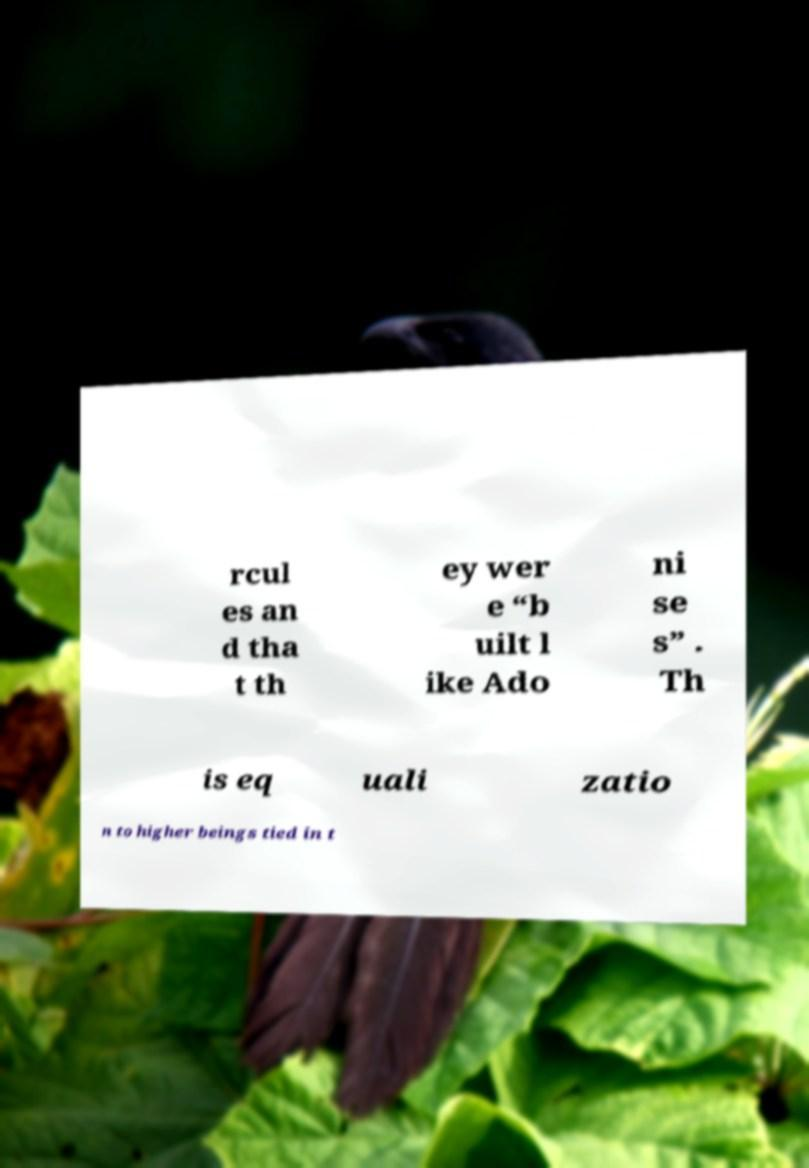Can you accurately transcribe the text from the provided image for me? rcul es an d tha t th ey wer e “b uilt l ike Ado ni se s” . Th is eq uali zatio n to higher beings tied in t 